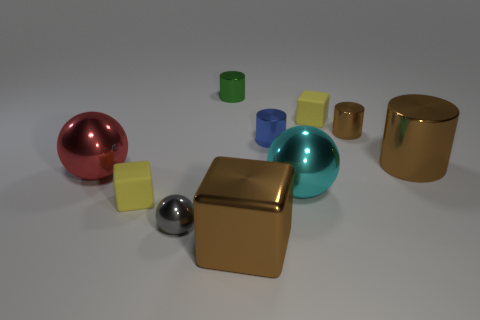There is a tiny thing that is in front of the tiny green metallic thing and behind the small brown cylinder; what is its shape?
Offer a terse response. Cube. What number of objects are big red objects that are behind the large block or big metallic objects to the right of the red thing?
Provide a short and direct response. 4. How many other objects are the same size as the red sphere?
Offer a very short reply. 3. Is the color of the block in front of the tiny ball the same as the large shiny cylinder?
Give a very brief answer. Yes. There is a block that is to the right of the gray metal object and to the left of the tiny blue object; how big is it?
Offer a terse response. Large. What number of large things are matte blocks or green objects?
Provide a short and direct response. 0. What is the shape of the matte thing that is in front of the red metallic thing?
Provide a short and direct response. Cube. How many red cylinders are there?
Your answer should be very brief. 0. Are there more small blue cylinders that are in front of the cyan thing than metal blocks?
Provide a short and direct response. No. How many objects are either large metal blocks or yellow rubber things on the left side of the big brown block?
Your response must be concise. 2. 